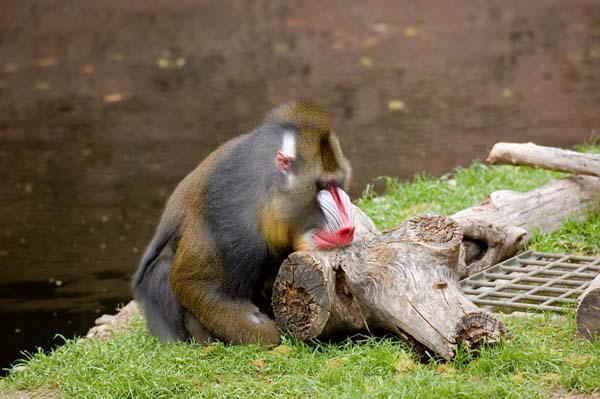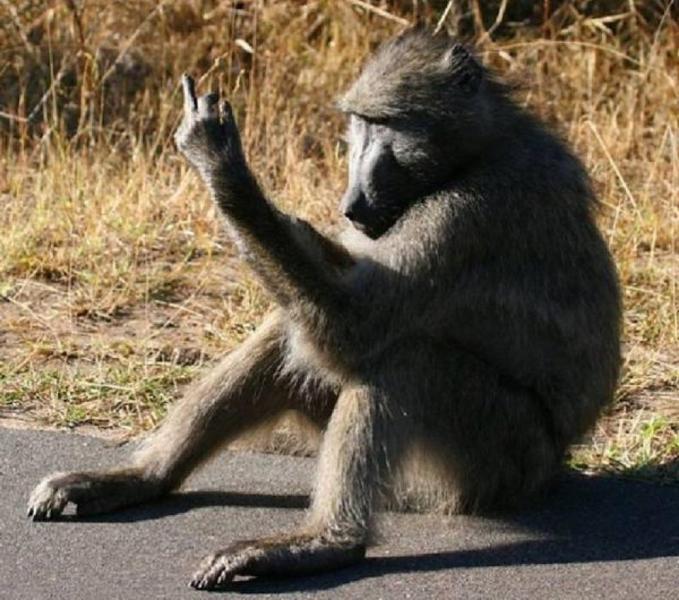The first image is the image on the left, the second image is the image on the right. For the images displayed, is the sentence "One of the images features two mandrils; mom and baby." factually correct? Answer yes or no. No. 